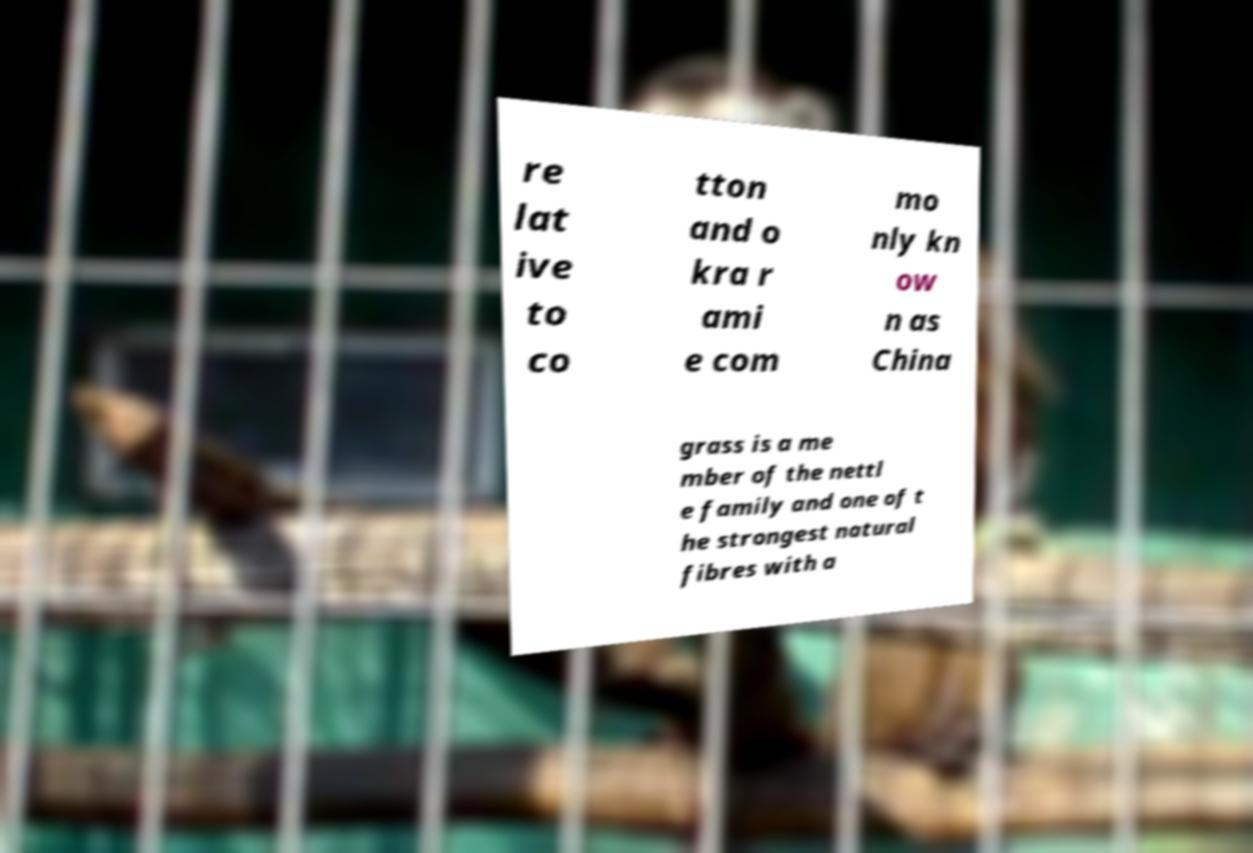There's text embedded in this image that I need extracted. Can you transcribe it verbatim? re lat ive to co tton and o kra r ami e com mo nly kn ow n as China grass is a me mber of the nettl e family and one of t he strongest natural fibres with a 